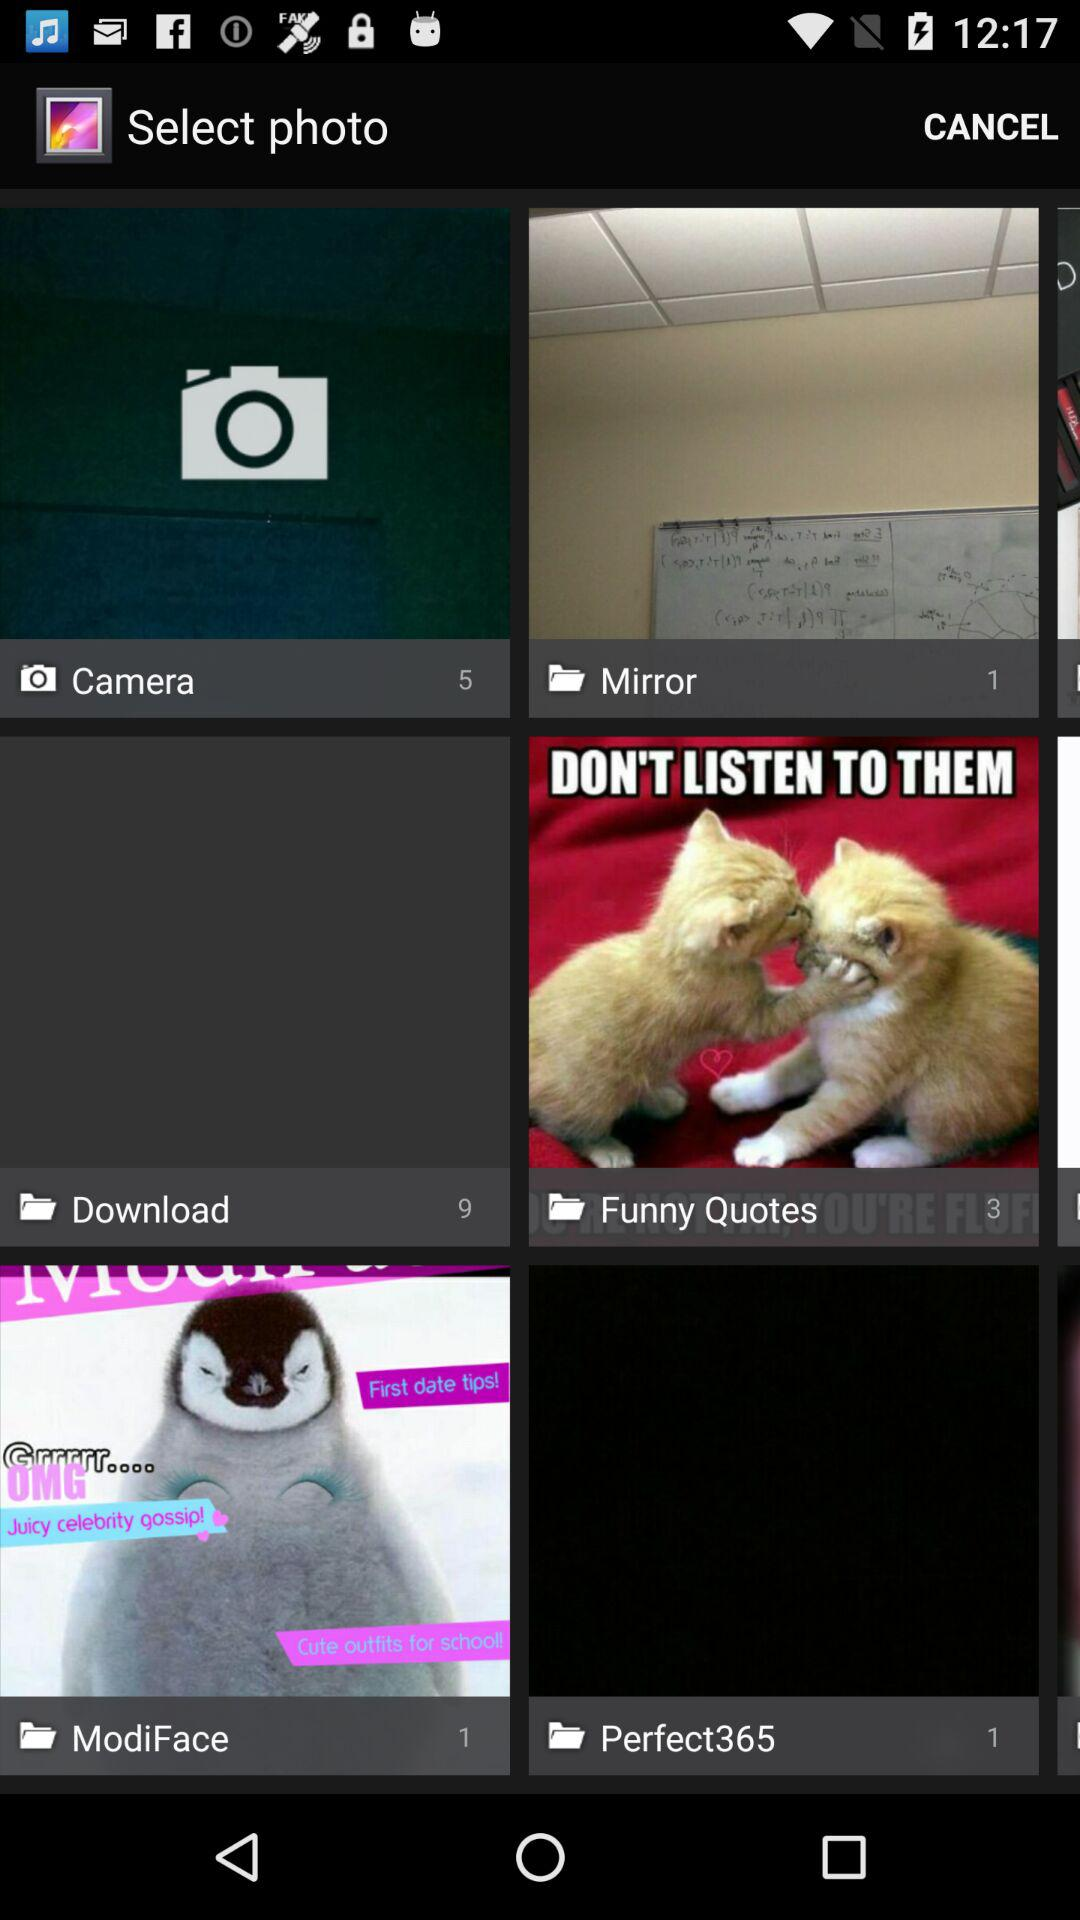How many photographs are in the "Funny Quotes"? There are 3 photographs. 